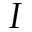<formula> <loc_0><loc_0><loc_500><loc_500>I</formula> 